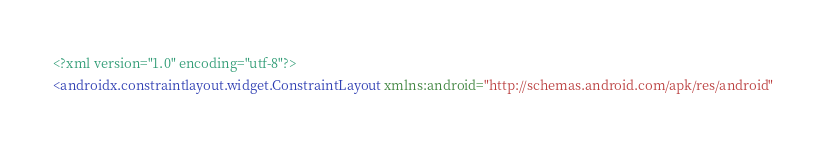<code> <loc_0><loc_0><loc_500><loc_500><_XML_><?xml version="1.0" encoding="utf-8"?>
<androidx.constraintlayout.widget.ConstraintLayout xmlns:android="http://schemas.android.com/apk/res/android"</code> 